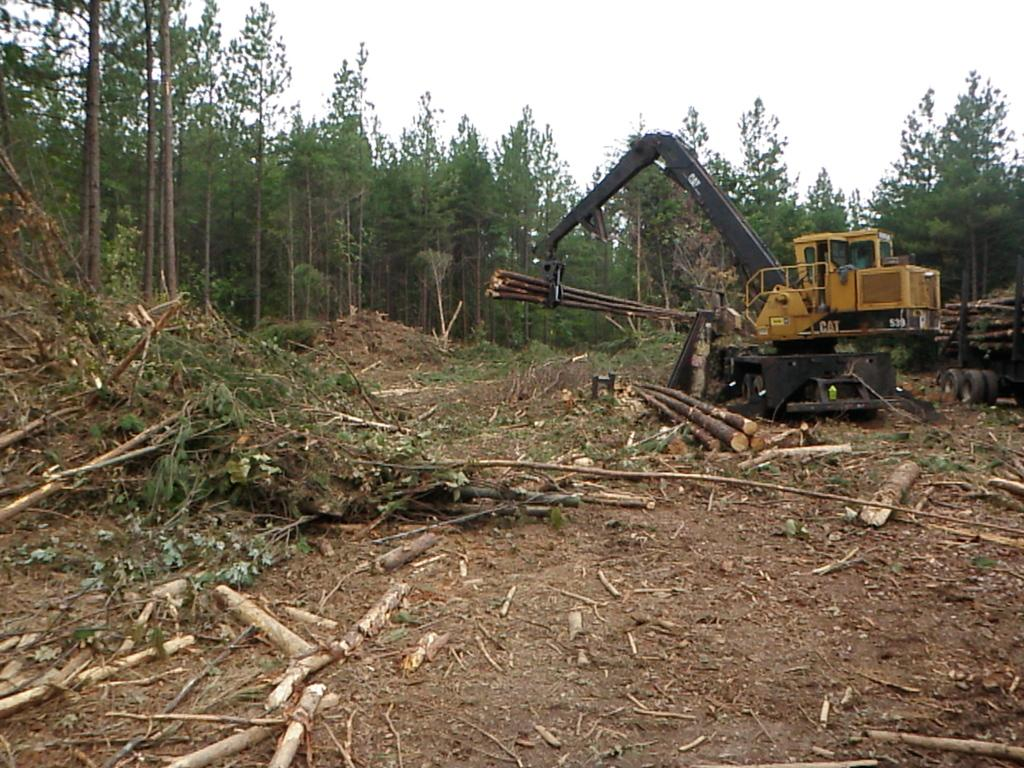What type of machinery is present in the image? There is an excavator in the image. What objects are made of wood in the image? There are wooden logs, wooden sticks, and cut down branches in the image. What type of rubber objects can be seen in the image? There are tyres in the image. What type of vegetation is present in the image? There are leaves and trees in the image. What is visible in the background of the image? The sky is visible in the background of the image. What flavor of ice cream is being served at the construction site in the image? There is no ice cream present in the image, and the image does not depict a construction site. 